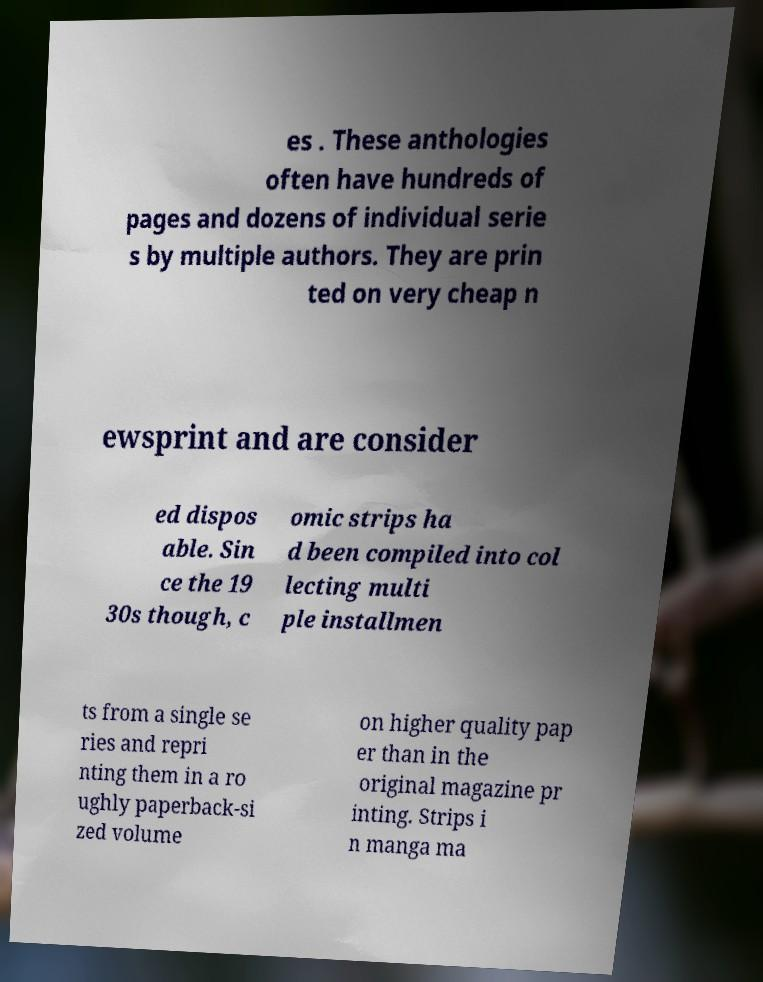I need the written content from this picture converted into text. Can you do that? es . These anthologies often have hundreds of pages and dozens of individual serie s by multiple authors. They are prin ted on very cheap n ewsprint and are consider ed dispos able. Sin ce the 19 30s though, c omic strips ha d been compiled into col lecting multi ple installmen ts from a single se ries and repri nting them in a ro ughly paperback-si zed volume on higher quality pap er than in the original magazine pr inting. Strips i n manga ma 